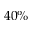<formula> <loc_0><loc_0><loc_500><loc_500>4 0 \%</formula> 